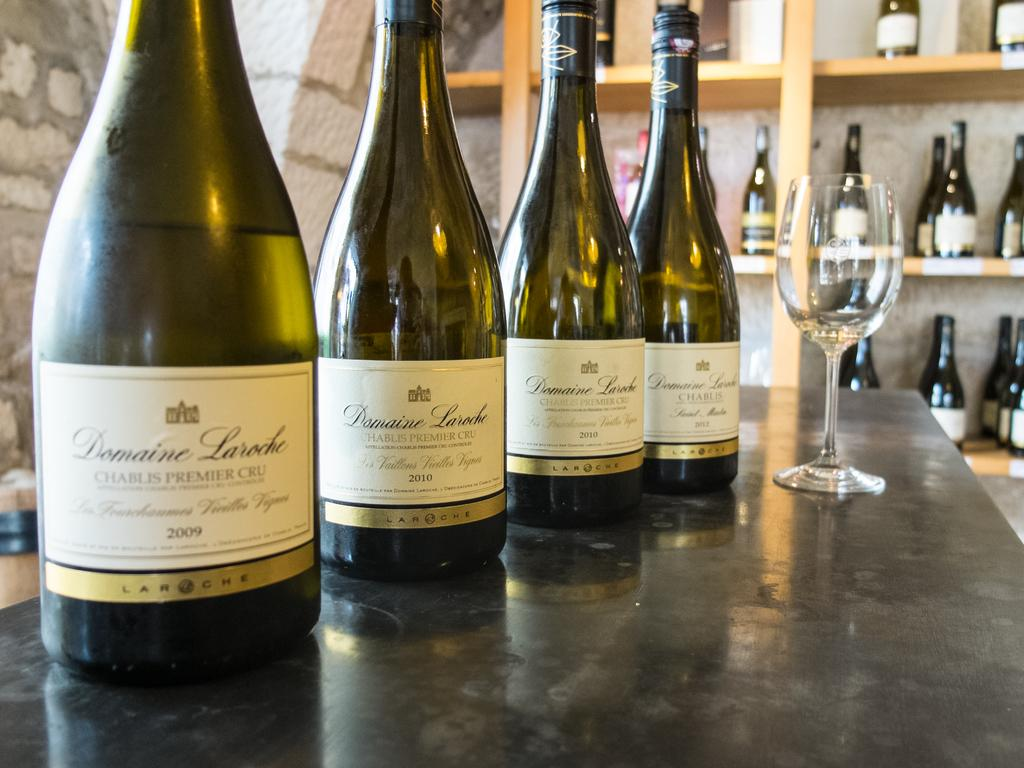<image>
Provide a brief description of the given image. Four wine bottles of Domaine Laroche on a counter with a wine glass with several bottles in the background. 